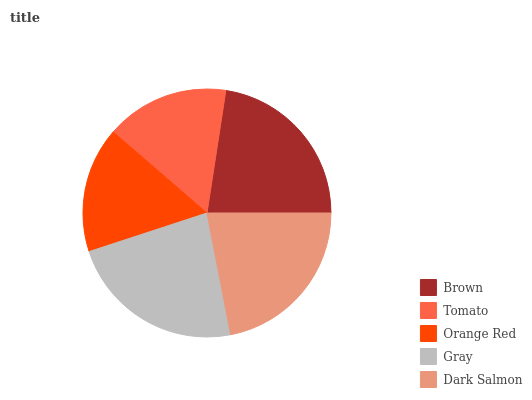Is Tomato the minimum?
Answer yes or no. Yes. Is Gray the maximum?
Answer yes or no. Yes. Is Orange Red the minimum?
Answer yes or no. No. Is Orange Red the maximum?
Answer yes or no. No. Is Orange Red greater than Tomato?
Answer yes or no. Yes. Is Tomato less than Orange Red?
Answer yes or no. Yes. Is Tomato greater than Orange Red?
Answer yes or no. No. Is Orange Red less than Tomato?
Answer yes or no. No. Is Dark Salmon the high median?
Answer yes or no. Yes. Is Dark Salmon the low median?
Answer yes or no. Yes. Is Tomato the high median?
Answer yes or no. No. Is Gray the low median?
Answer yes or no. No. 